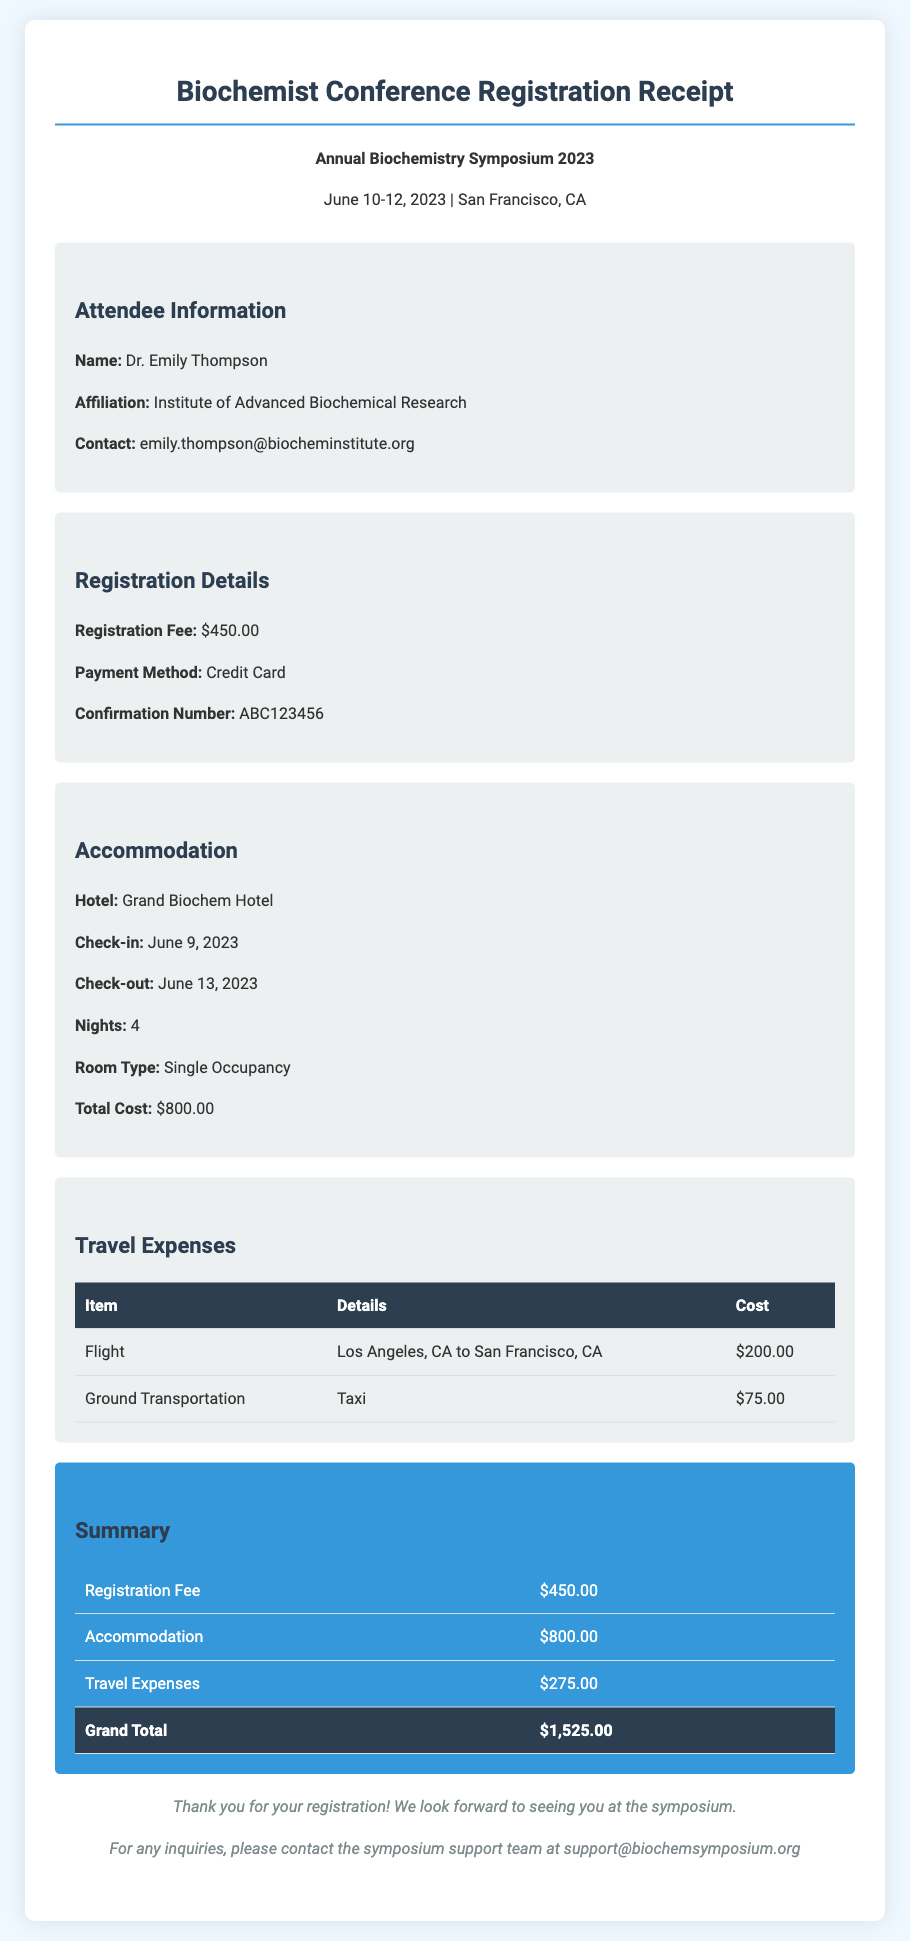What is the name of the attendee? The name of the attendee is provided in the attendee information section.
Answer: Dr. Emily Thompson What is the total cost of accommodation? The total cost of accommodation is stated in the accommodation section.
Answer: $800.00 What were the travel expenses for ground transportation? The travel expenses related to ground transportation is detailed in the travel expenses section.
Answer: $75.00 On which date does the symposium start? The start date of the symposium is mentioned at the top of the document.
Answer: June 10, 2023 What is the registration fee? The registration fee is outlined in the registration details section.
Answer: $450.00 How many nights is the accommodation booked for? The number of nights for accommodation is listed in the accommodation section.
Answer: 4 What payment method was used for the registration? The payment method used is described in the registration details section.
Answer: Credit Card What is the grand total amount? The grand total amount is calculated and shown in the summary section.
Answer: $1,525.00 What hotel is the attendee staying at? The name of the hotel is found in the accommodation section.
Answer: Grand Biochem Hotel 